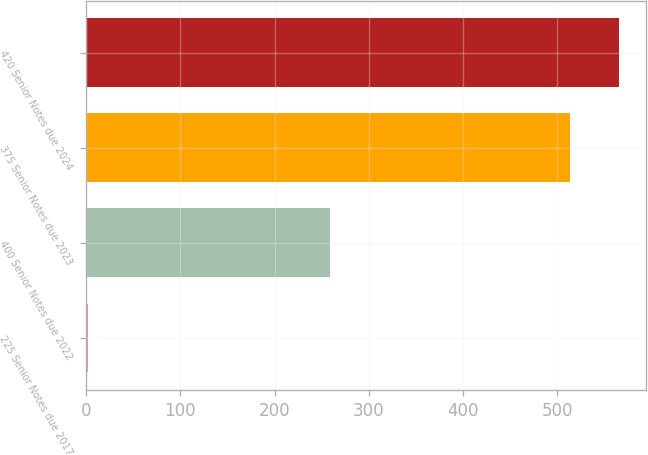Convert chart. <chart><loc_0><loc_0><loc_500><loc_500><bar_chart><fcel>225 Senior Notes due 2017<fcel>400 Senior Notes due 2022<fcel>375 Senior Notes due 2023<fcel>420 Senior Notes due 2024<nl><fcel>2.21<fcel>259<fcel>513.2<fcel>565.4<nl></chart> 